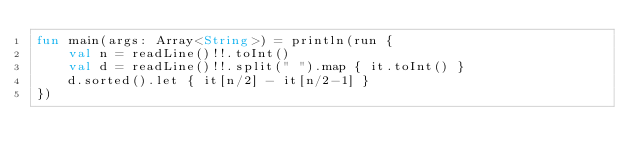Convert code to text. <code><loc_0><loc_0><loc_500><loc_500><_Kotlin_>fun main(args: Array<String>) = println(run {
    val n = readLine()!!.toInt()
    val d = readLine()!!.split(" ").map { it.toInt() }
    d.sorted().let { it[n/2] - it[n/2-1] }
})</code> 